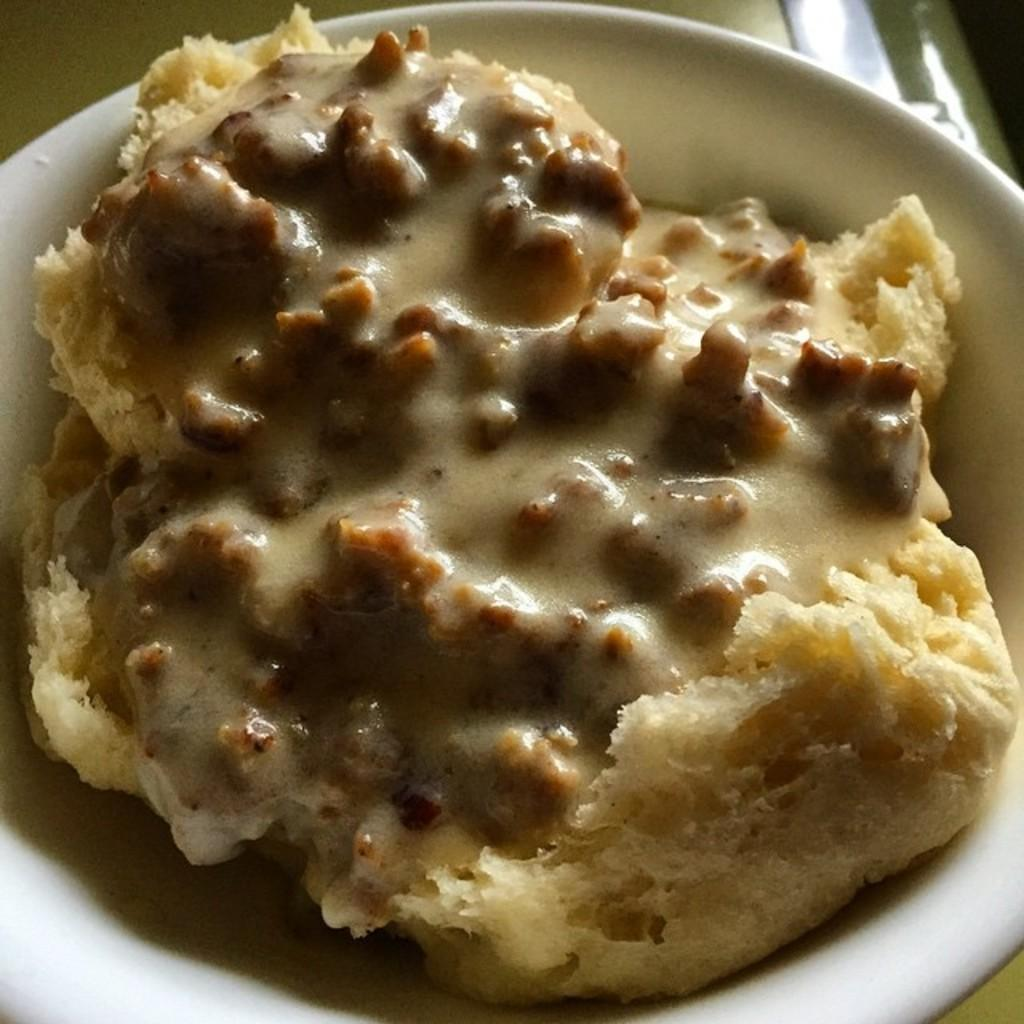What is the main object in the center of the image? There is a white color palette in the center of the image. What is on the palette? The palette contains food items. Can you describe the background of the image? There are objects in the background of the image. Is there a quill used for writing on the palette in the image? No, there is no quill present on the palette or in the image. 